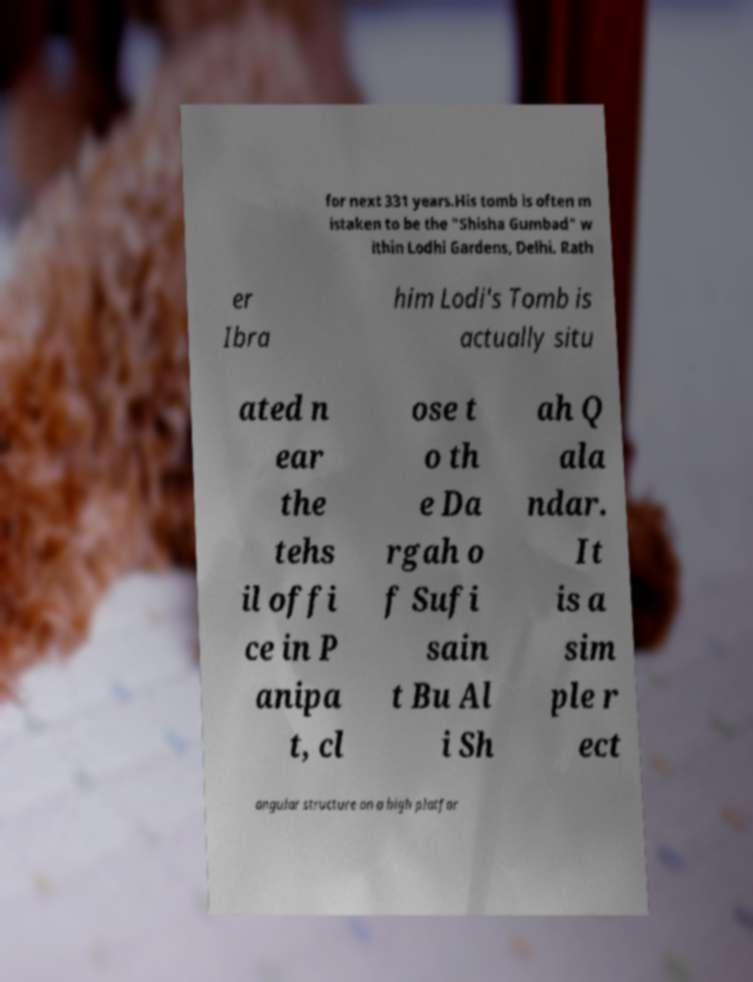What messages or text are displayed in this image? I need them in a readable, typed format. for next 331 years.His tomb is often m istaken to be the "Shisha Gumbad" w ithin Lodhi Gardens, Delhi. Rath er Ibra him Lodi's Tomb is actually situ ated n ear the tehs il offi ce in P anipa t, cl ose t o th e Da rgah o f Sufi sain t Bu Al i Sh ah Q ala ndar. It is a sim ple r ect angular structure on a high platfor 